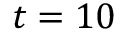Convert formula to latex. <formula><loc_0><loc_0><loc_500><loc_500>t = 1 0</formula> 